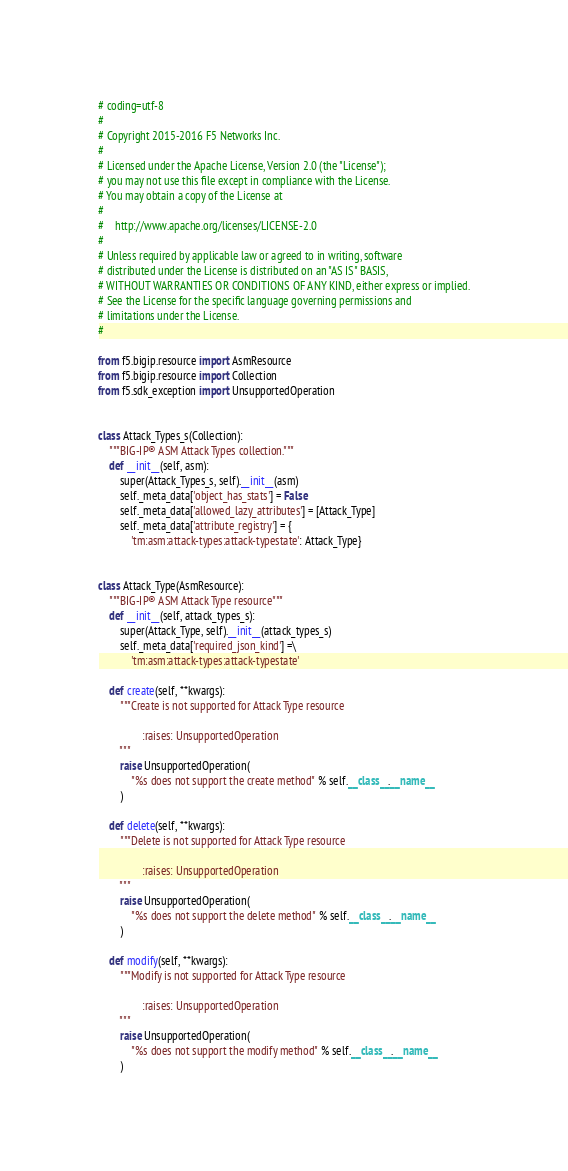<code> <loc_0><loc_0><loc_500><loc_500><_Python_># coding=utf-8
#
# Copyright 2015-2016 F5 Networks Inc.
#
# Licensed under the Apache License, Version 2.0 (the "License");
# you may not use this file except in compliance with the License.
# You may obtain a copy of the License at
#
#    http://www.apache.org/licenses/LICENSE-2.0
#
# Unless required by applicable law or agreed to in writing, software
# distributed under the License is distributed on an "AS IS" BASIS,
# WITHOUT WARRANTIES OR CONDITIONS OF ANY KIND, either express or implied.
# See the License for the specific language governing permissions and
# limitations under the License.
#

from f5.bigip.resource import AsmResource
from f5.bigip.resource import Collection
from f5.sdk_exception import UnsupportedOperation


class Attack_Types_s(Collection):
    """BIG-IP® ASM Attack Types collection."""
    def __init__(self, asm):
        super(Attack_Types_s, self).__init__(asm)
        self._meta_data['object_has_stats'] = False
        self._meta_data['allowed_lazy_attributes'] = [Attack_Type]
        self._meta_data['attribute_registry'] = {
            'tm:asm:attack-types:attack-typestate': Attack_Type}


class Attack_Type(AsmResource):
    """BIG-IP® ASM Attack Type resource"""
    def __init__(self, attack_types_s):
        super(Attack_Type, self).__init__(attack_types_s)
        self._meta_data['required_json_kind'] =\
            'tm:asm:attack-types:attack-typestate'

    def create(self, **kwargs):
        """Create is not supported for Attack Type resource

                :raises: UnsupportedOperation
        """
        raise UnsupportedOperation(
            "%s does not support the create method" % self.__class__.__name__
        )

    def delete(self, **kwargs):
        """Delete is not supported for Attack Type resource

                :raises: UnsupportedOperation
        """
        raise UnsupportedOperation(
            "%s does not support the delete method" % self.__class__.__name__
        )

    def modify(self, **kwargs):
        """Modify is not supported for Attack Type resource

                :raises: UnsupportedOperation
        """
        raise UnsupportedOperation(
            "%s does not support the modify method" % self.__class__.__name__
        )
</code> 